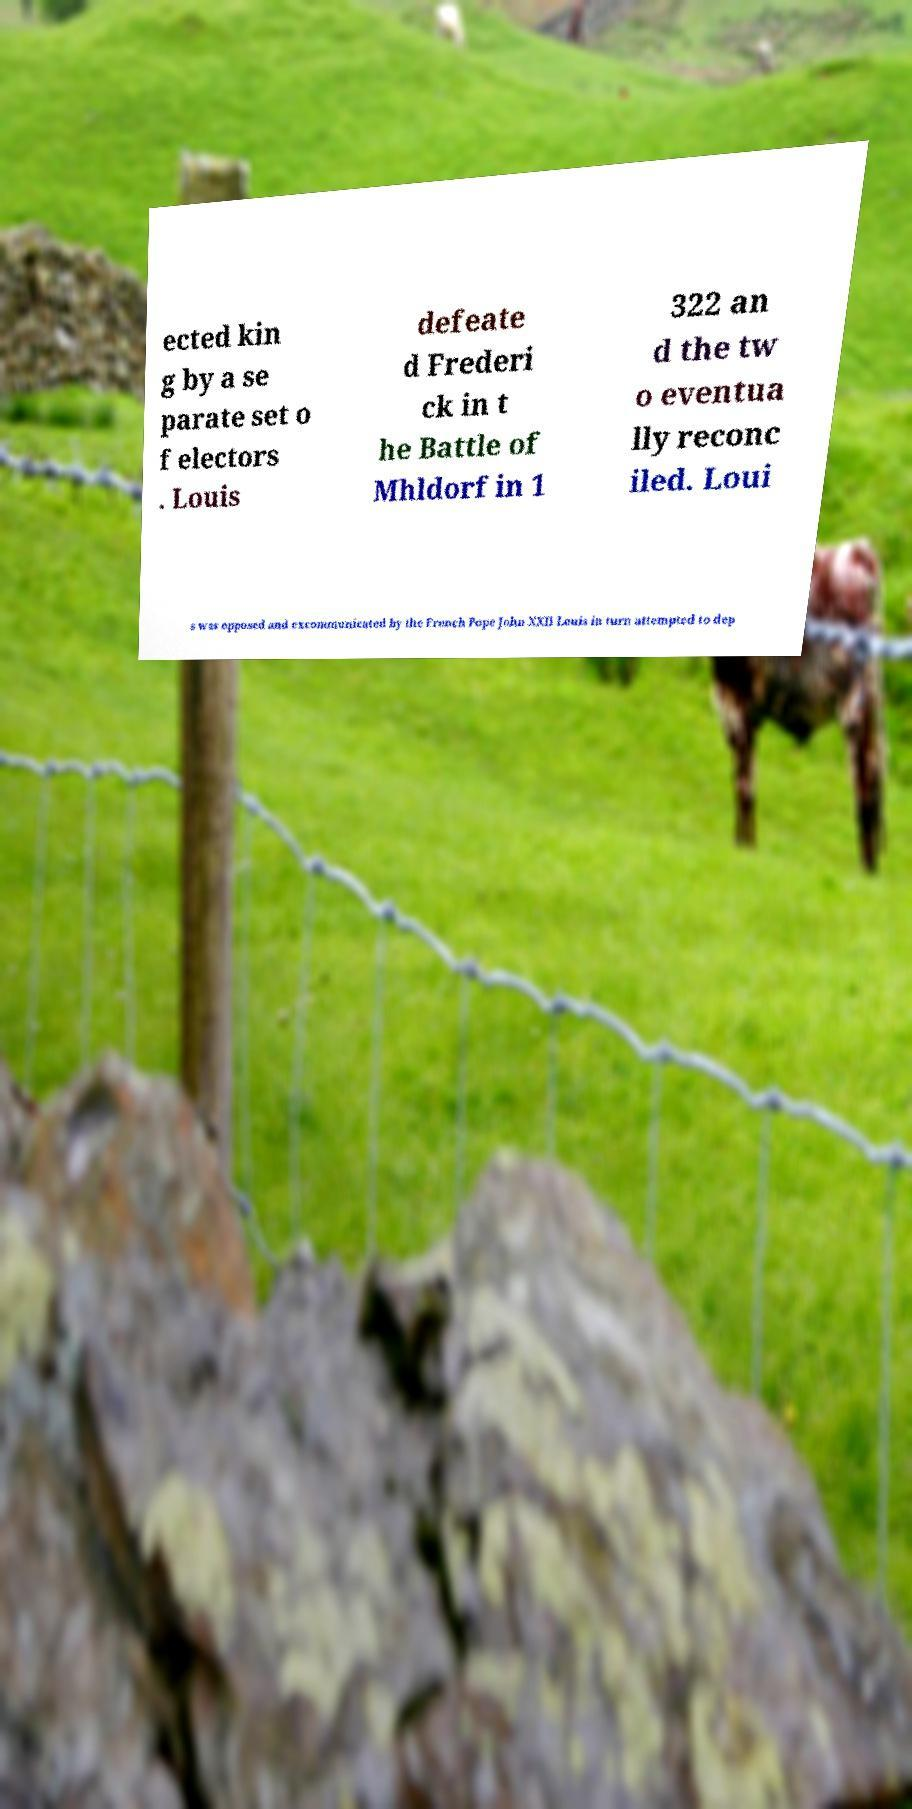Please read and relay the text visible in this image. What does it say? ected kin g by a se parate set o f electors . Louis defeate d Frederi ck in t he Battle of Mhldorf in 1 322 an d the tw o eventua lly reconc iled. Loui s was opposed and excommunicated by the French Pope John XXII Louis in turn attempted to dep 